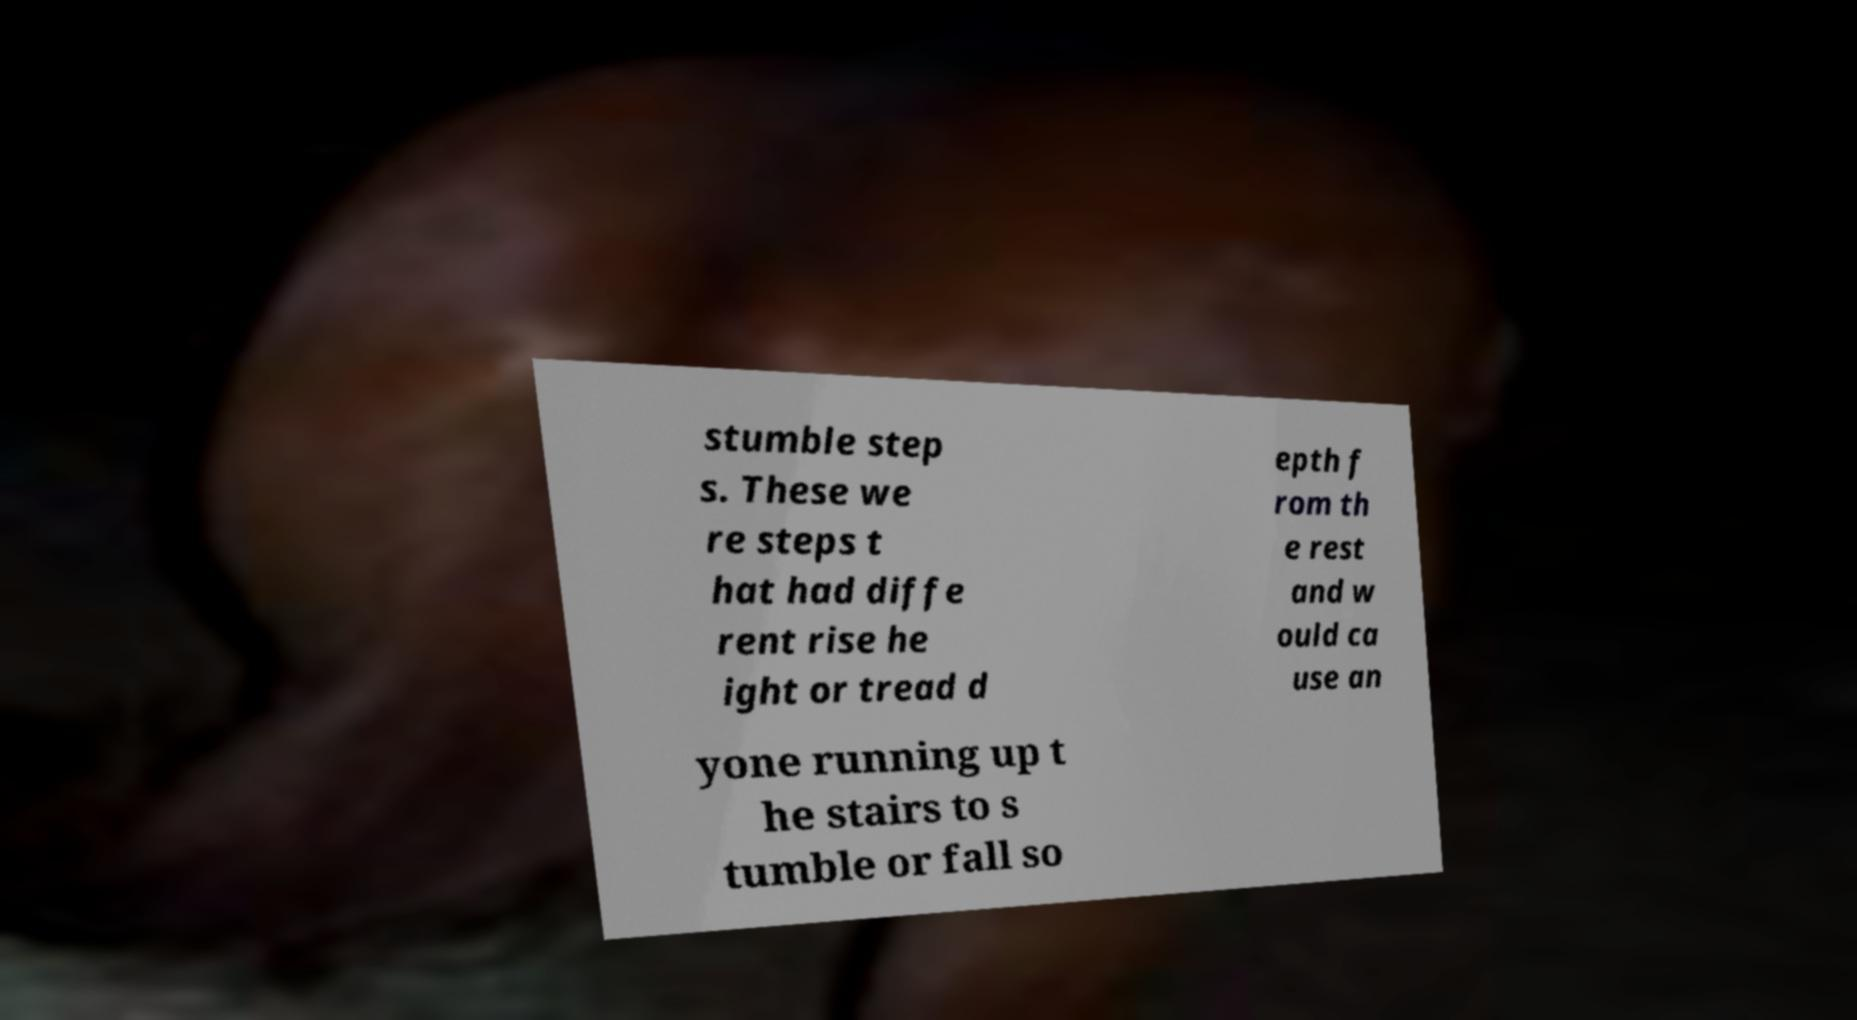Could you assist in decoding the text presented in this image and type it out clearly? stumble step s. These we re steps t hat had diffe rent rise he ight or tread d epth f rom th e rest and w ould ca use an yone running up t he stairs to s tumble or fall so 